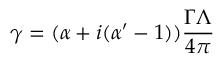<formula> <loc_0><loc_0><loc_500><loc_500>\gamma = ( \alpha + i ( \alpha ^ { \prime } - 1 ) ) \frac { \Gamma \Lambda } { 4 \pi }</formula> 